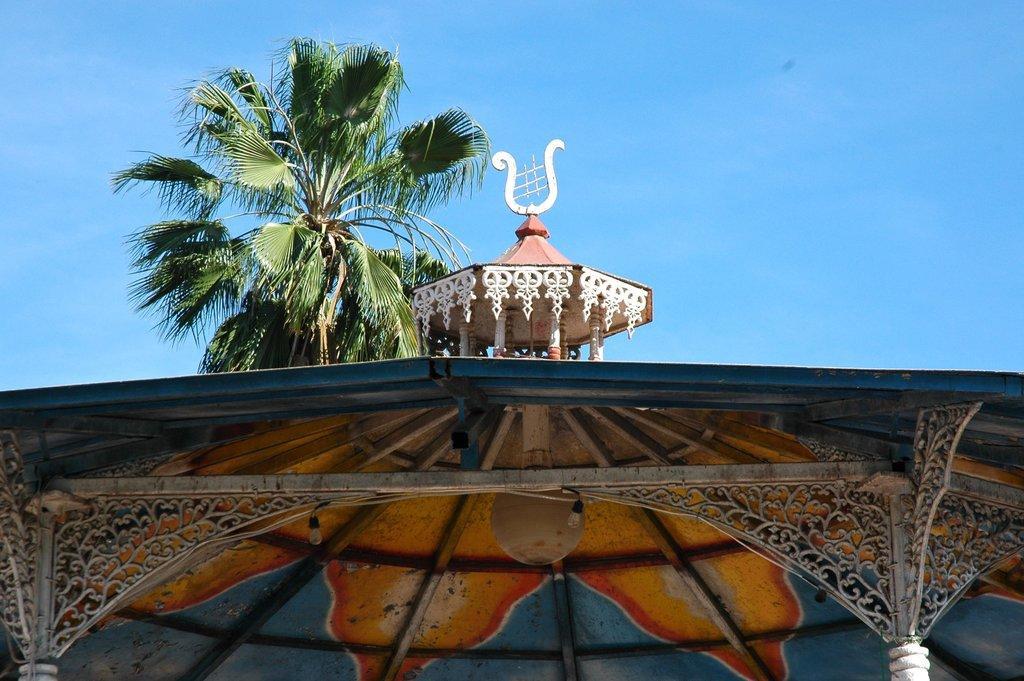How would you summarize this image in a sentence or two? In this image we can see some lights and some poles on the roof. In the background, we can see a tree and the sky. 